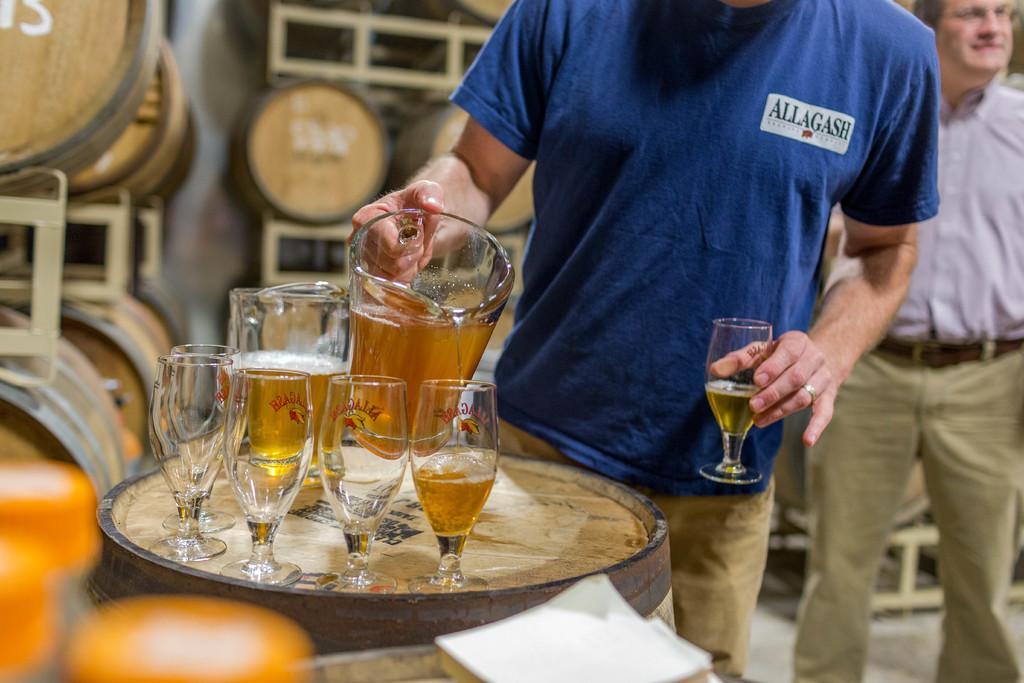Describe this image in one or two sentences. In front of this picture, we see a drum on which five glasses and a jar are placed. The man in blue t-shirt is catching a jar of wine in his hands and on the other hand, he is carrying a glass with wine in it and behind him, we see a man in purple t-shirt purple shirt is wearing spectacles and he is smiling. Behind them, we see many drums. 